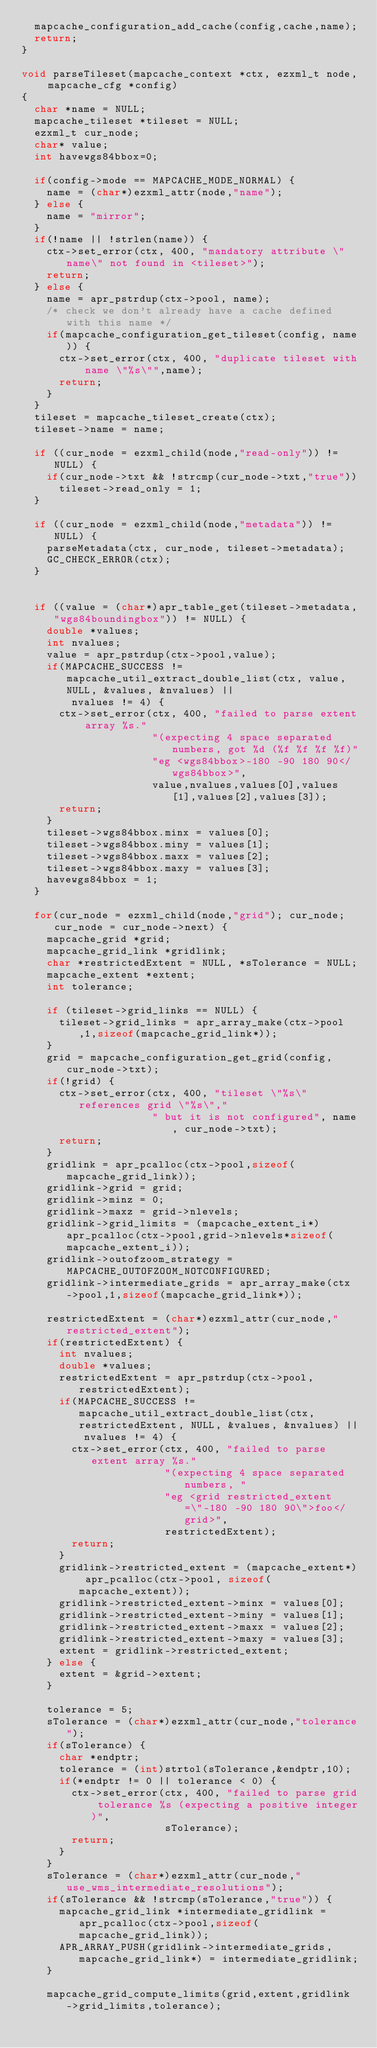<code> <loc_0><loc_0><loc_500><loc_500><_C_>  mapcache_configuration_add_cache(config,cache,name);
  return;
}

void parseTileset(mapcache_context *ctx, ezxml_t node, mapcache_cfg *config)
{
  char *name = NULL;
  mapcache_tileset *tileset = NULL;
  ezxml_t cur_node;
  char* value;
  int havewgs84bbox=0;

  if(config->mode == MAPCACHE_MODE_NORMAL) {
    name = (char*)ezxml_attr(node,"name");
  } else {
    name = "mirror";
  }
  if(!name || !strlen(name)) {
    ctx->set_error(ctx, 400, "mandatory attribute \"name\" not found in <tileset>");
    return;
  } else {
    name = apr_pstrdup(ctx->pool, name);
    /* check we don't already have a cache defined with this name */
    if(mapcache_configuration_get_tileset(config, name)) {
      ctx->set_error(ctx, 400, "duplicate tileset with name \"%s\"",name);
      return;
    }
  }
  tileset = mapcache_tileset_create(ctx);
  tileset->name = name;

  if ((cur_node = ezxml_child(node,"read-only")) != NULL) {
    if(cur_node->txt && !strcmp(cur_node->txt,"true"))
      tileset->read_only = 1;
  }

  if ((cur_node = ezxml_child(node,"metadata")) != NULL) {
    parseMetadata(ctx, cur_node, tileset->metadata);
    GC_CHECK_ERROR(ctx);
  }


  if ((value = (char*)apr_table_get(tileset->metadata,"wgs84boundingbox")) != NULL) {
    double *values;
    int nvalues;
    value = apr_pstrdup(ctx->pool,value);
    if(MAPCACHE_SUCCESS != mapcache_util_extract_double_list(ctx, value, NULL, &values, &nvalues) ||
        nvalues != 4) {
      ctx->set_error(ctx, 400, "failed to parse extent array %s."
                     "(expecting 4 space separated numbers, got %d (%f %f %f %f)"
                     "eg <wgs84bbox>-180 -90 180 90</wgs84bbox>",
                     value,nvalues,values[0],values[1],values[2],values[3]);
      return;
    }
    tileset->wgs84bbox.minx = values[0];
    tileset->wgs84bbox.miny = values[1];
    tileset->wgs84bbox.maxx = values[2];
    tileset->wgs84bbox.maxy = values[3];
    havewgs84bbox = 1;
  }

  for(cur_node = ezxml_child(node,"grid"); cur_node; cur_node = cur_node->next) {
    mapcache_grid *grid;
    mapcache_grid_link *gridlink;
    char *restrictedExtent = NULL, *sTolerance = NULL;
    mapcache_extent *extent;
    int tolerance;

    if (tileset->grid_links == NULL) {
      tileset->grid_links = apr_array_make(ctx->pool,1,sizeof(mapcache_grid_link*));
    }
    grid = mapcache_configuration_get_grid(config, cur_node->txt);
    if(!grid) {
      ctx->set_error(ctx, 400, "tileset \"%s\" references grid \"%s\","
                     " but it is not configured", name, cur_node->txt);
      return;
    }
    gridlink = apr_pcalloc(ctx->pool,sizeof(mapcache_grid_link));
    gridlink->grid = grid;
    gridlink->minz = 0;
    gridlink->maxz = grid->nlevels;
    gridlink->grid_limits = (mapcache_extent_i*)apr_pcalloc(ctx->pool,grid->nlevels*sizeof(mapcache_extent_i));
    gridlink->outofzoom_strategy = MAPCACHE_OUTOFZOOM_NOTCONFIGURED;
    gridlink->intermediate_grids = apr_array_make(ctx->pool,1,sizeof(mapcache_grid_link*));

    restrictedExtent = (char*)ezxml_attr(cur_node,"restricted_extent");
    if(restrictedExtent) {
      int nvalues;
      double *values;
      restrictedExtent = apr_pstrdup(ctx->pool,restrictedExtent);
      if(MAPCACHE_SUCCESS != mapcache_util_extract_double_list(ctx, restrictedExtent, NULL, &values, &nvalues) ||
          nvalues != 4) {
        ctx->set_error(ctx, 400, "failed to parse extent array %s."
                       "(expecting 4 space separated numbers, "
                       "eg <grid restricted_extent=\"-180 -90 180 90\">foo</grid>",
                       restrictedExtent);
        return;
      }
      gridlink->restricted_extent = (mapcache_extent*) apr_pcalloc(ctx->pool, sizeof(mapcache_extent));
      gridlink->restricted_extent->minx = values[0];
      gridlink->restricted_extent->miny = values[1];
      gridlink->restricted_extent->maxx = values[2];
      gridlink->restricted_extent->maxy = values[3];
      extent = gridlink->restricted_extent;
    } else {
      extent = &grid->extent;
    }

    tolerance = 5;
    sTolerance = (char*)ezxml_attr(cur_node,"tolerance");
    if(sTolerance) {
      char *endptr;
      tolerance = (int)strtol(sTolerance,&endptr,10);
      if(*endptr != 0 || tolerance < 0) {
        ctx->set_error(ctx, 400, "failed to parse grid tolerance %s (expecting a positive integer)",
                       sTolerance);
        return;
      }
    }
    sTolerance = (char*)ezxml_attr(cur_node,"use_wms_intermediate_resolutions");
    if(sTolerance && !strcmp(sTolerance,"true")) {
      mapcache_grid_link *intermediate_gridlink = apr_pcalloc(ctx->pool,sizeof(mapcache_grid_link));
      APR_ARRAY_PUSH(gridlink->intermediate_grids,mapcache_grid_link*) = intermediate_gridlink;
    }

    mapcache_grid_compute_limits(grid,extent,gridlink->grid_limits,tolerance);
</code> 